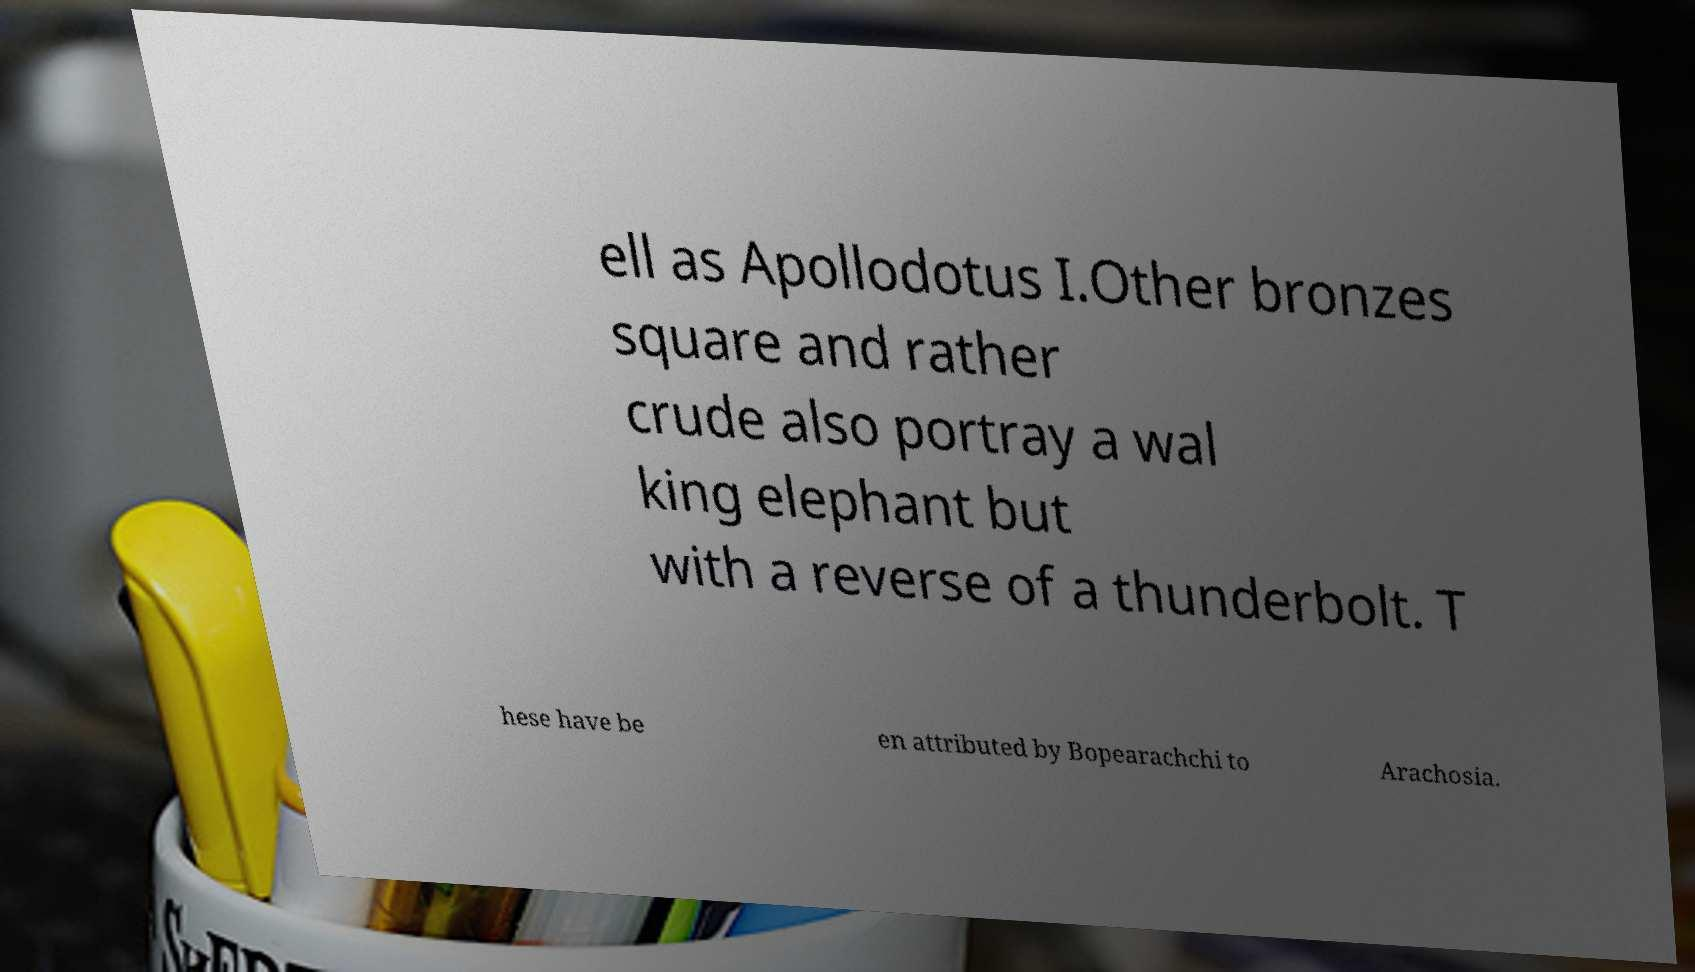Could you extract and type out the text from this image? ell as Apollodotus I.Other bronzes square and rather crude also portray a wal king elephant but with a reverse of a thunderbolt. T hese have be en attributed by Bopearachchi to Arachosia. 